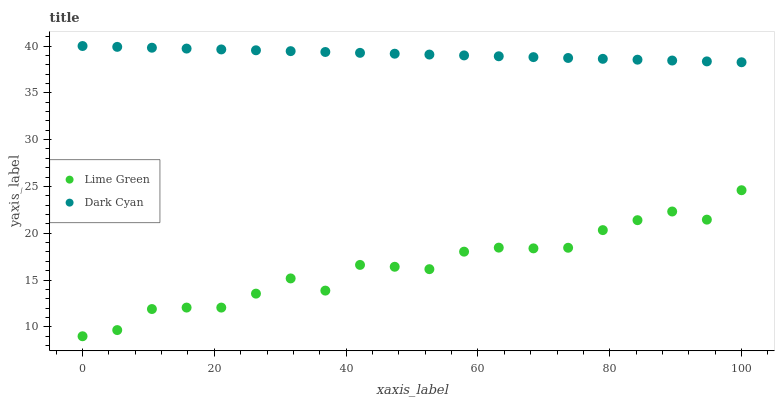Does Lime Green have the minimum area under the curve?
Answer yes or no. Yes. Does Dark Cyan have the maximum area under the curve?
Answer yes or no. Yes. Does Lime Green have the maximum area under the curve?
Answer yes or no. No. Is Dark Cyan the smoothest?
Answer yes or no. Yes. Is Lime Green the roughest?
Answer yes or no. Yes. Is Lime Green the smoothest?
Answer yes or no. No. Does Lime Green have the lowest value?
Answer yes or no. Yes. Does Dark Cyan have the highest value?
Answer yes or no. Yes. Does Lime Green have the highest value?
Answer yes or no. No. Is Lime Green less than Dark Cyan?
Answer yes or no. Yes. Is Dark Cyan greater than Lime Green?
Answer yes or no. Yes. Does Lime Green intersect Dark Cyan?
Answer yes or no. No. 